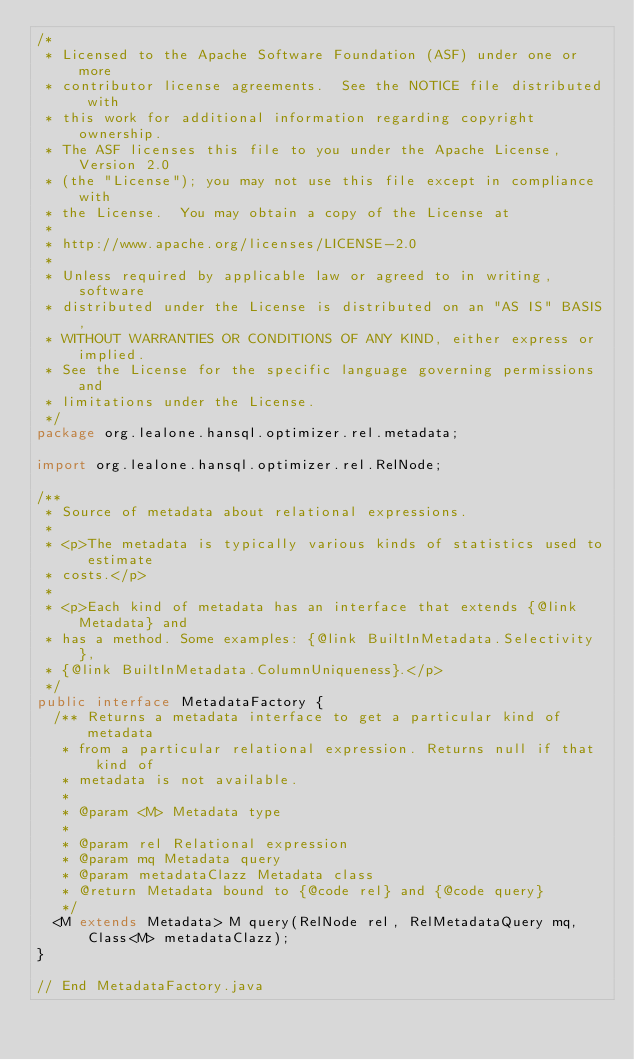Convert code to text. <code><loc_0><loc_0><loc_500><loc_500><_Java_>/*
 * Licensed to the Apache Software Foundation (ASF) under one or more
 * contributor license agreements.  See the NOTICE file distributed with
 * this work for additional information regarding copyright ownership.
 * The ASF licenses this file to you under the Apache License, Version 2.0
 * (the "License"); you may not use this file except in compliance with
 * the License.  You may obtain a copy of the License at
 *
 * http://www.apache.org/licenses/LICENSE-2.0
 *
 * Unless required by applicable law or agreed to in writing, software
 * distributed under the License is distributed on an "AS IS" BASIS,
 * WITHOUT WARRANTIES OR CONDITIONS OF ANY KIND, either express or implied.
 * See the License for the specific language governing permissions and
 * limitations under the License.
 */
package org.lealone.hansql.optimizer.rel.metadata;

import org.lealone.hansql.optimizer.rel.RelNode;

/**
 * Source of metadata about relational expressions.
 *
 * <p>The metadata is typically various kinds of statistics used to estimate
 * costs.</p>
 *
 * <p>Each kind of metadata has an interface that extends {@link Metadata} and
 * has a method. Some examples: {@link BuiltInMetadata.Selectivity},
 * {@link BuiltInMetadata.ColumnUniqueness}.</p>
 */
public interface MetadataFactory {
  /** Returns a metadata interface to get a particular kind of metadata
   * from a particular relational expression. Returns null if that kind of
   * metadata is not available.
   *
   * @param <M> Metadata type
   *
   * @param rel Relational expression
   * @param mq Metadata query
   * @param metadataClazz Metadata class
   * @return Metadata bound to {@code rel} and {@code query}
   */
  <M extends Metadata> M query(RelNode rel, RelMetadataQuery mq,
      Class<M> metadataClazz);
}

// End MetadataFactory.java
</code> 